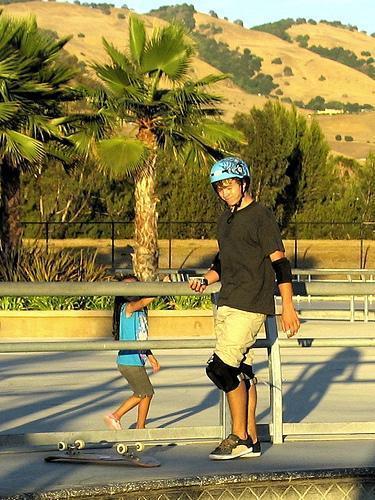How many skateboards are on the ground?
Give a very brief answer. 1. How many people are there?
Give a very brief answer. 2. How many horses are running?
Give a very brief answer. 0. 